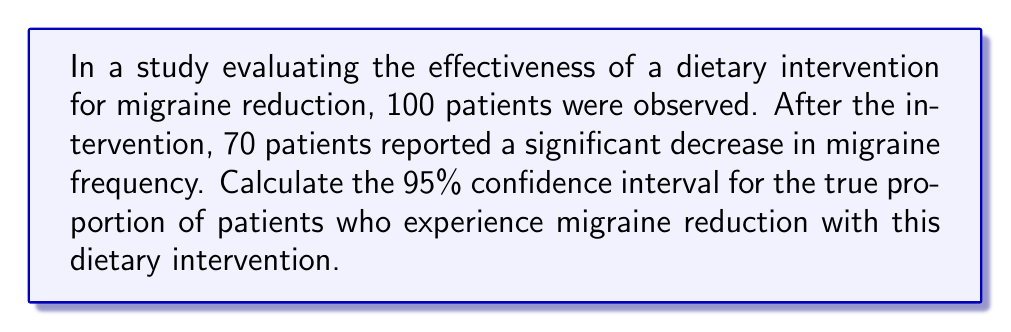Help me with this question. To calculate the confidence interval, we'll use the normal approximation method for a proportion:

1. Calculate the sample proportion:
   $\hat{p} = \frac{70}{100} = 0.70$

2. Calculate the standard error:
   $SE = \sqrt{\frac{\hat{p}(1-\hat{p})}{n}} = \sqrt{\frac{0.70(1-0.70)}{100}} = \sqrt{\frac{0.21}{100}} = 0.0458$

3. For a 95% confidence interval, use $z_{0.025} = 1.96$

4. Calculate the margin of error:
   $E = z_{0.025} \times SE = 1.96 \times 0.0458 = 0.0898$

5. Compute the confidence interval:
   $CI = \hat{p} \pm E = 0.70 \pm 0.0898$

   Lower bound: $0.70 - 0.0898 = 0.6102$
   Upper bound: $0.70 + 0.0898 = 0.7898$

Therefore, the 95% confidence interval is (0.6102, 0.7898).
Answer: (0.6102, 0.7898) 